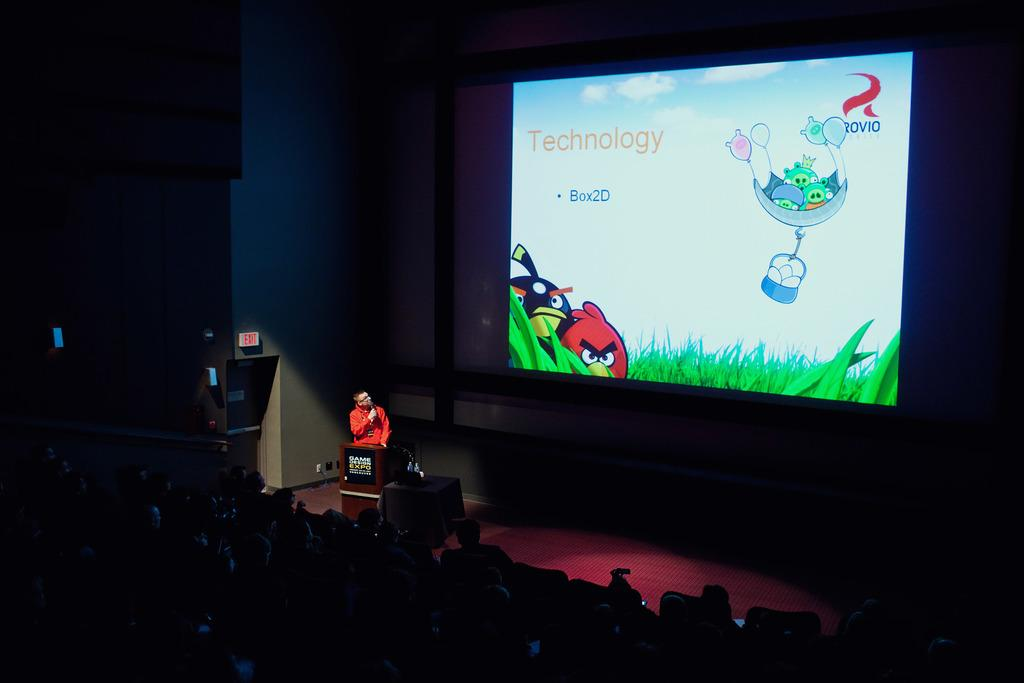<image>
Share a concise interpretation of the image provided. A screen at a presentation has the word Technology as its heading. 